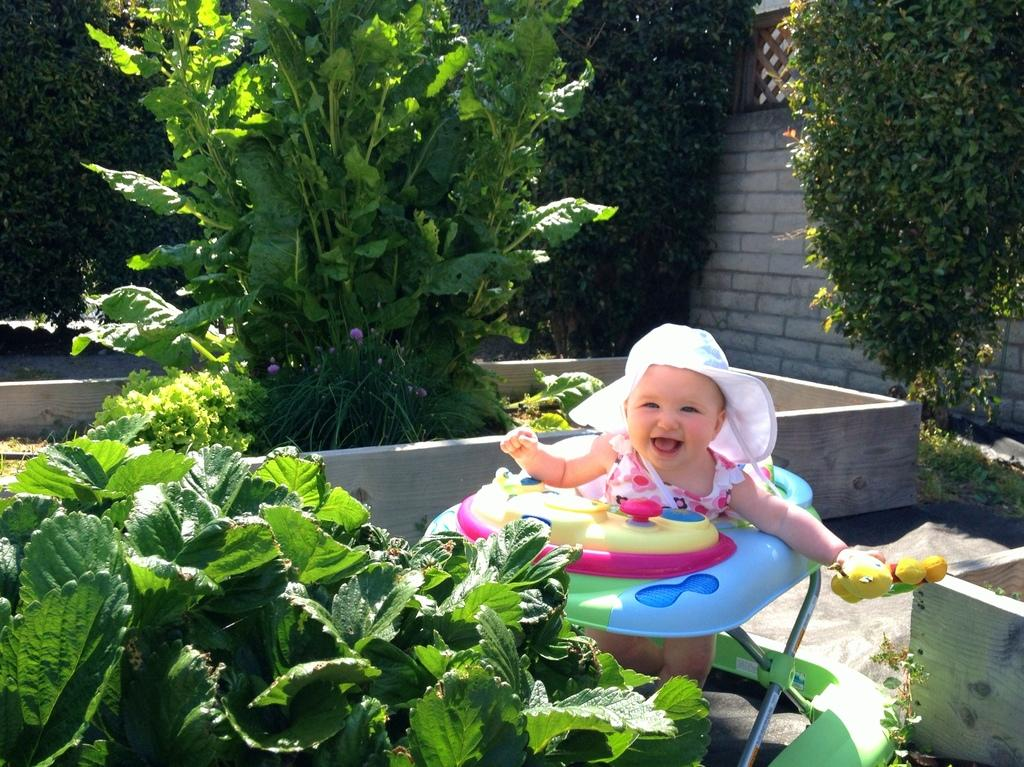What is the main subject of the image? There is a baby in the image. What is the baby doing in the image? The baby is smiling. What is the baby wearing on their head? The baby is wearing a white hat. What type of vegetation can be seen on the ground in the image? There are plants and trees on the ground. What is visible in the background of the image? There is a wall in the background of the image. What type of corn is being harvested by the baby in the image? There is no corn present in the image, and the baby is not harvesting anything. How many cubs are visible in the image? There are no cubs present in the image. 